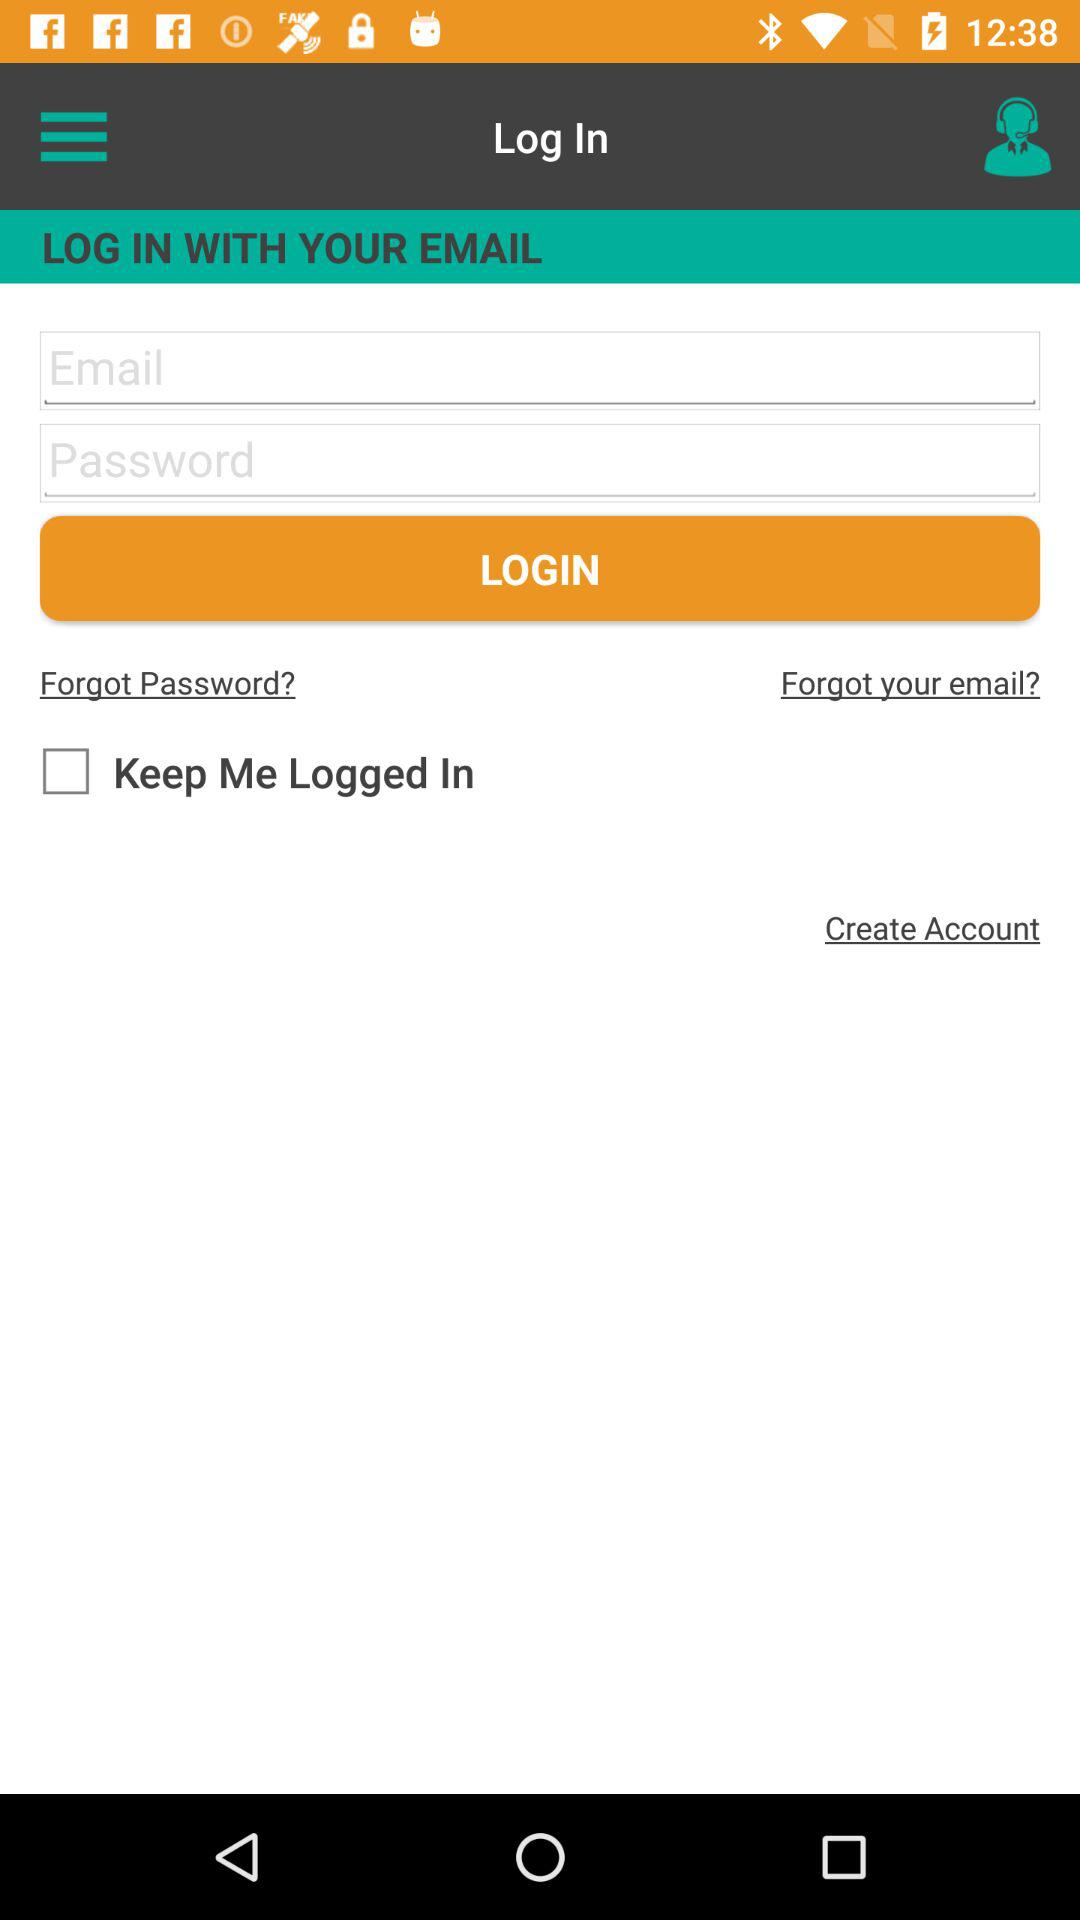Can we reset email address?
When the provided information is insufficient, respond with <no answer>. <no answer> 